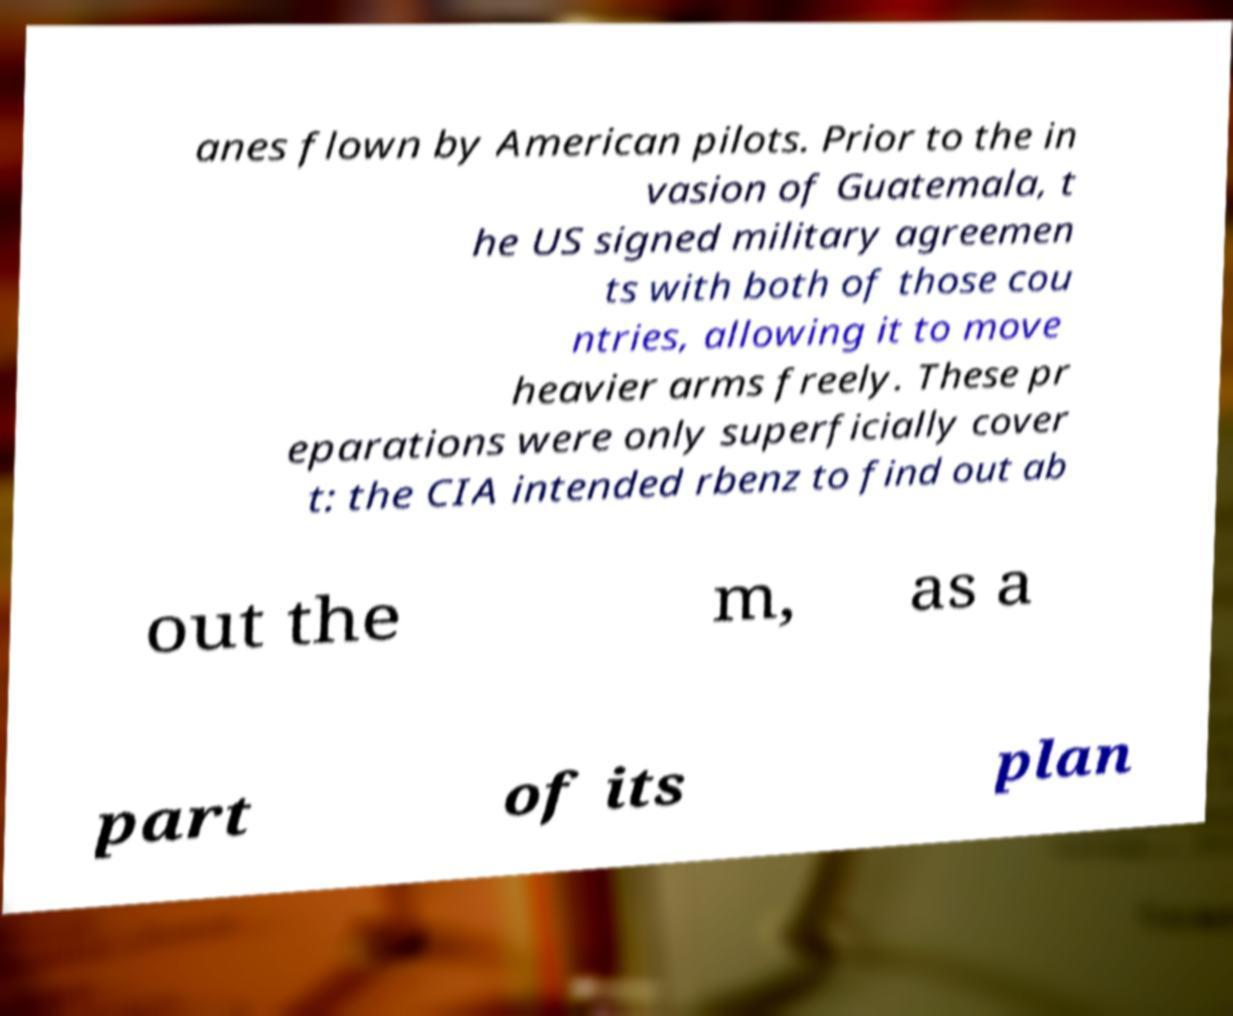I need the written content from this picture converted into text. Can you do that? anes flown by American pilots. Prior to the in vasion of Guatemala, t he US signed military agreemen ts with both of those cou ntries, allowing it to move heavier arms freely. These pr eparations were only superficially cover t: the CIA intended rbenz to find out ab out the m, as a part of its plan 